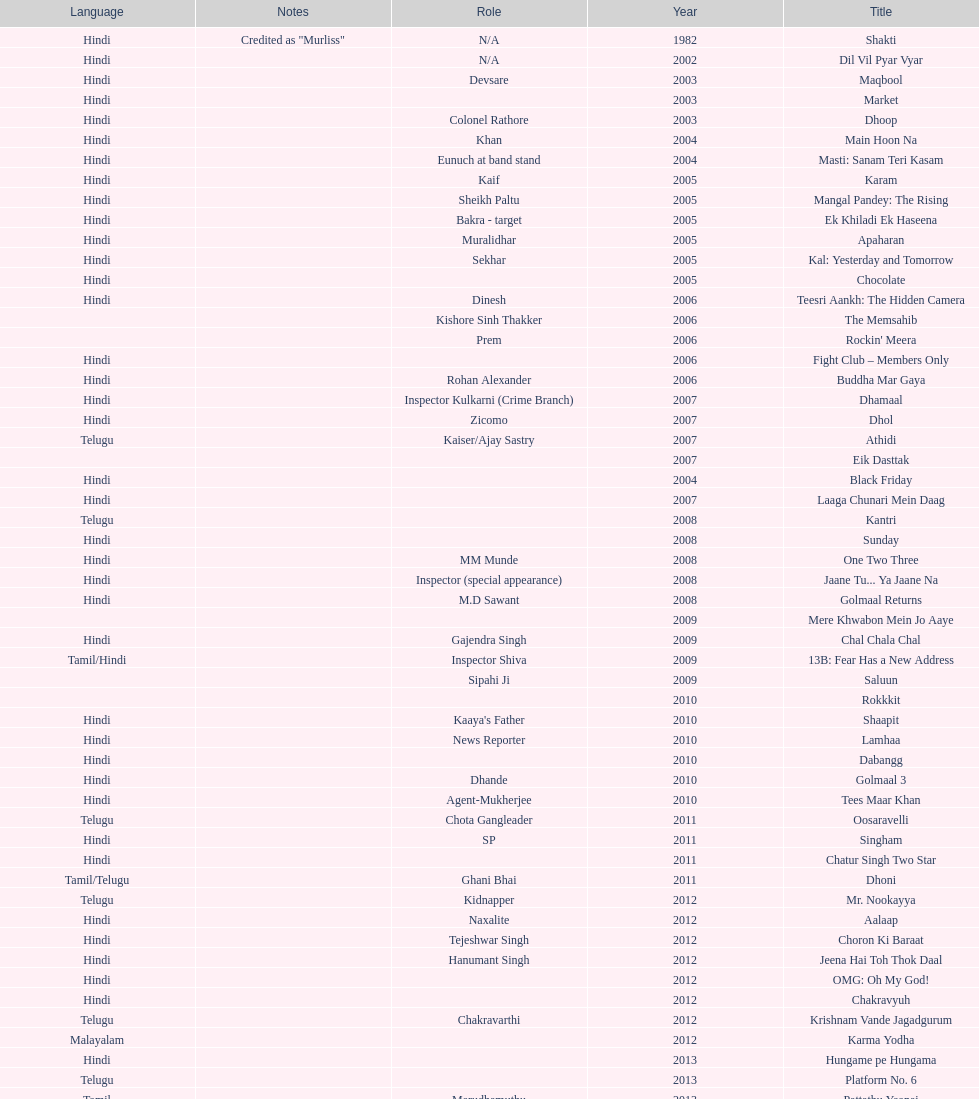What movie did this actor star in after they starred in dil vil pyar vyar in 2002? Maqbool. 